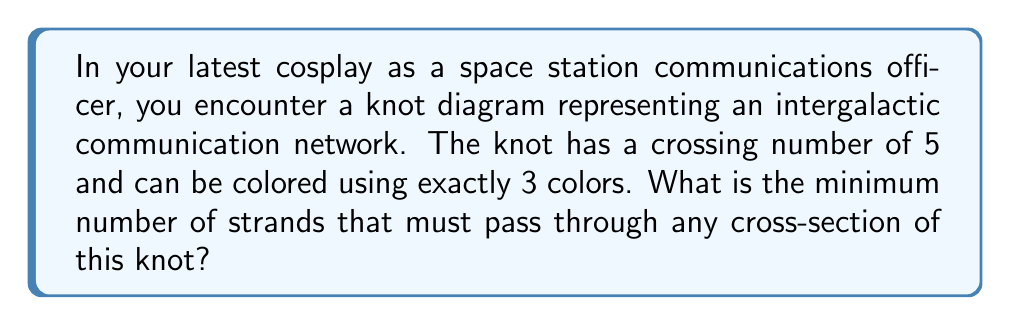Teach me how to tackle this problem. Let's approach this step-by-step:

1) First, recall that the colorability of a knot is related to its determinant. A knot is n-colorable if and only if n divides the determinant of the knot.

2) Given that the knot can be colored using exactly 3 colors, we know that 3 must divide the determinant of the knot, but 4 must not.

3) The determinant of a knot is always odd. The smallest odd number divisible by 3 but not by 4 is 3 itself.

4) Therefore, the determinant of this knot must be 3.

5) Now, we can use the relationship between the determinant and the number of spanning trees of the Tait graph of the knot. The number of spanning trees is equal to the determinant.

6) The Tait graph of a knot with n crossings has n vertices. Let's call the number of spanning trees T(n).

7) For a connected graph with n vertices, the minimum number of spanning trees is n. This occurs when the graph is a tree itself.

8) However, we know that T(n) = 3 in this case, which is less than n = 5 (the number of crossings).

9) This is only possible if the Tait graph is not connected. The smallest number of components that could give T(n) = 3 is 3 components.

10) In a knot diagram, each component of the Tait graph corresponds to a region bounded by strands of the knot.

11) The number of regions minus 1 is equal to the minimum number of strands that must pass through any cross-section of the knot.

Therefore, the minimum number of strands passing through any cross-section is 2.
Answer: 2 